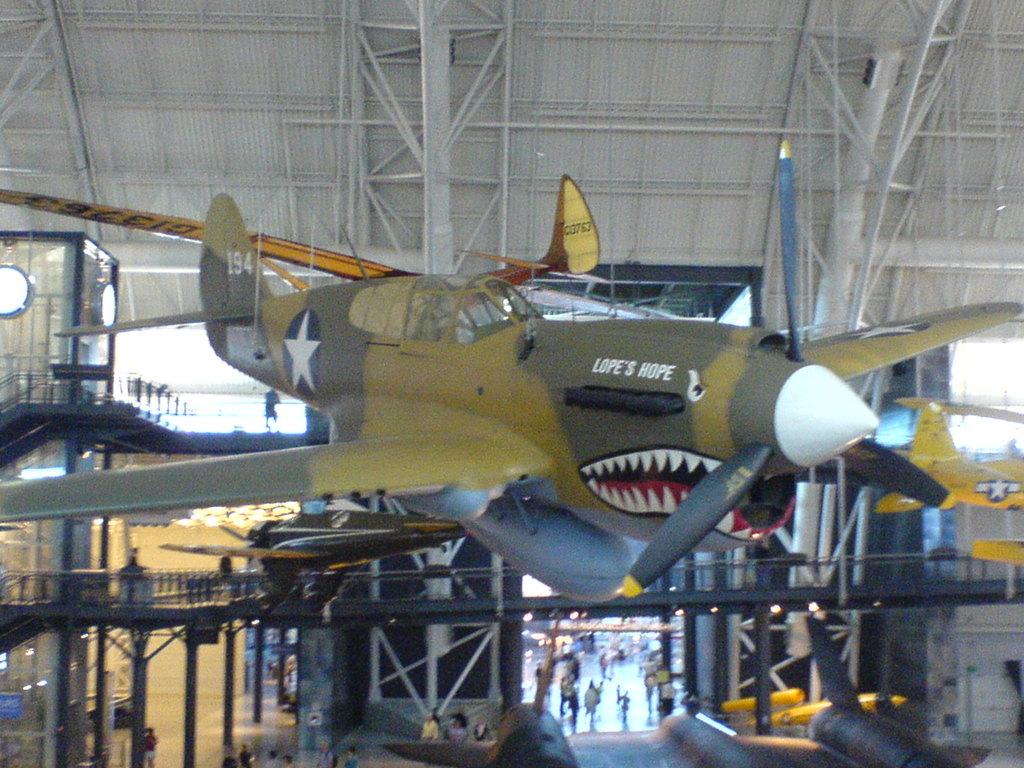What number is written on the tail of the plane?
Ensure brevity in your answer.  194. 